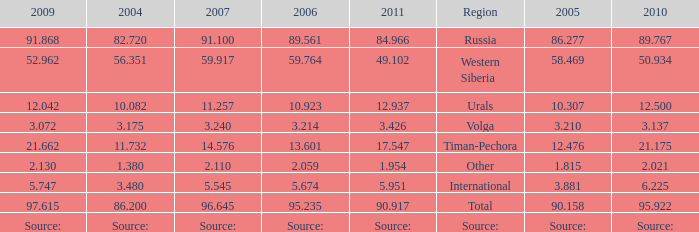What is the 2005 Lukoil oil prodroduction when in 2007 oil production 91.100 million tonnes? 86.277. 